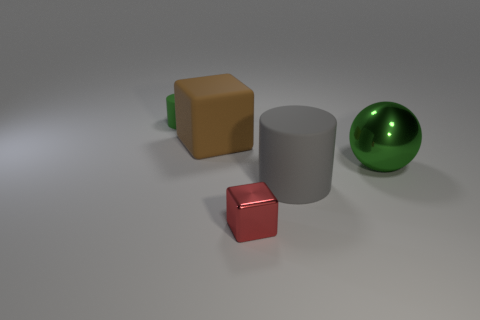Are there any other things that have the same shape as the green metal thing?
Provide a succinct answer. No. There is a object that is the same color as the tiny rubber cylinder; what material is it?
Offer a terse response. Metal. What is the size of the metal thing in front of the big matte object to the right of the metallic object that is in front of the big green object?
Provide a short and direct response. Small. There is a small rubber thing; is its shape the same as the large matte object that is in front of the big shiny object?
Your answer should be very brief. Yes. Is there a cylinder of the same color as the sphere?
Keep it short and to the point. Yes. What number of spheres are yellow things or red shiny things?
Make the answer very short. 0. Are there any tiny red objects of the same shape as the brown rubber thing?
Ensure brevity in your answer.  Yes. How many other things are there of the same color as the tiny shiny thing?
Provide a short and direct response. 0. Are there fewer big cylinders to the right of the large gray cylinder than small green cylinders?
Provide a short and direct response. Yes. How many blue cylinders are there?
Provide a succinct answer. 0. 